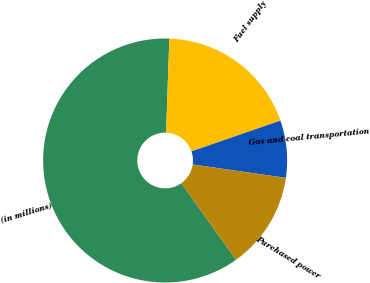Convert chart to OTSL. <chart><loc_0><loc_0><loc_500><loc_500><pie_chart><fcel>(in millions)<fcel>Fuel supply<fcel>Gas and coal transportation<fcel>Purchased power<nl><fcel>60.42%<fcel>19.15%<fcel>7.57%<fcel>12.86%<nl></chart> 